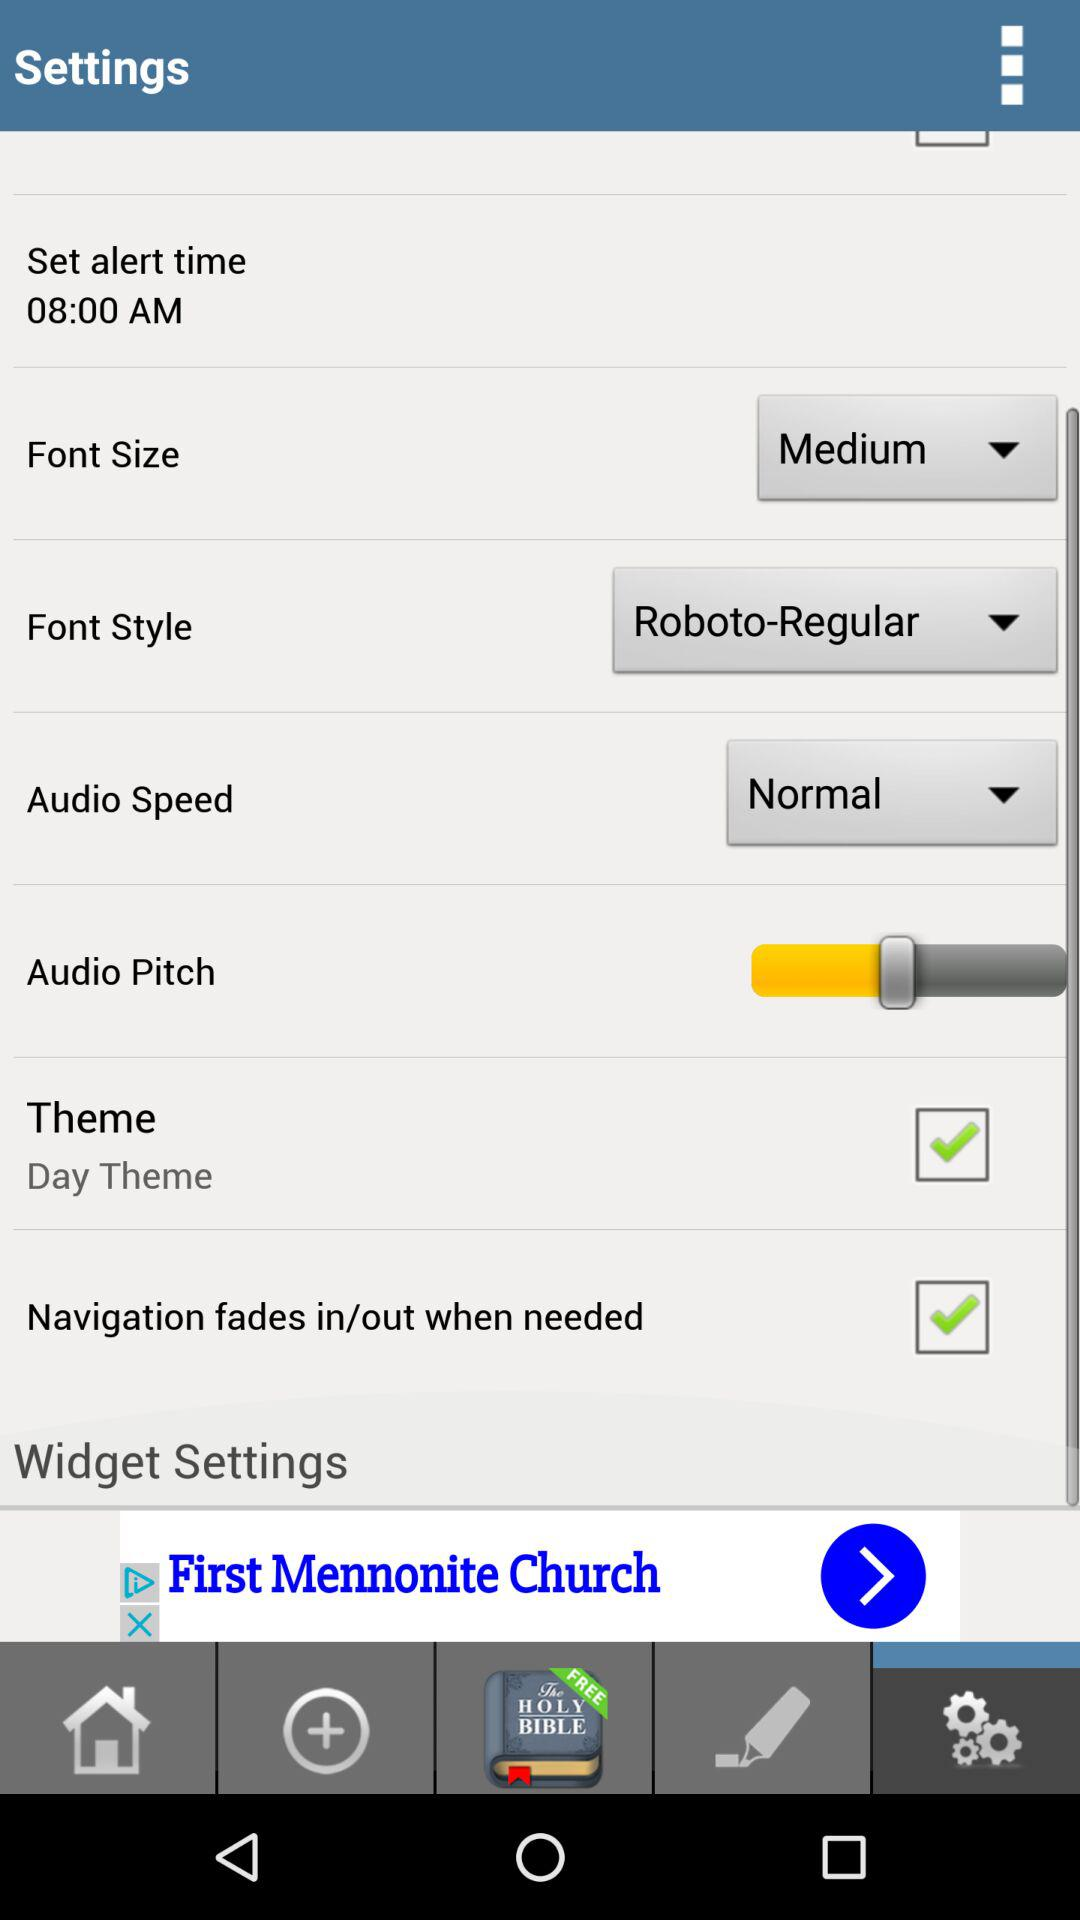What is the font size? The font size is medium. 